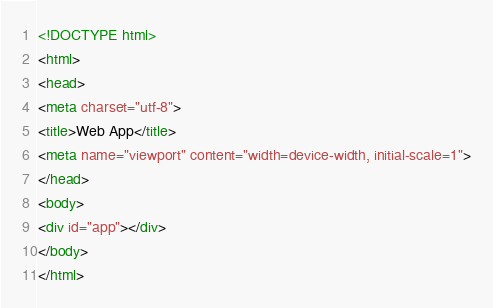Convert code to text. <code><loc_0><loc_0><loc_500><loc_500><_HTML_><!DOCTYPE html>
<html>
<head>
<meta charset="utf-8">
<title>Web App</title>
<meta name="viewport" content="width=device-width, initial-scale=1">
</head>
<body>
<div id="app"></div>
</body>
</html>
</code> 